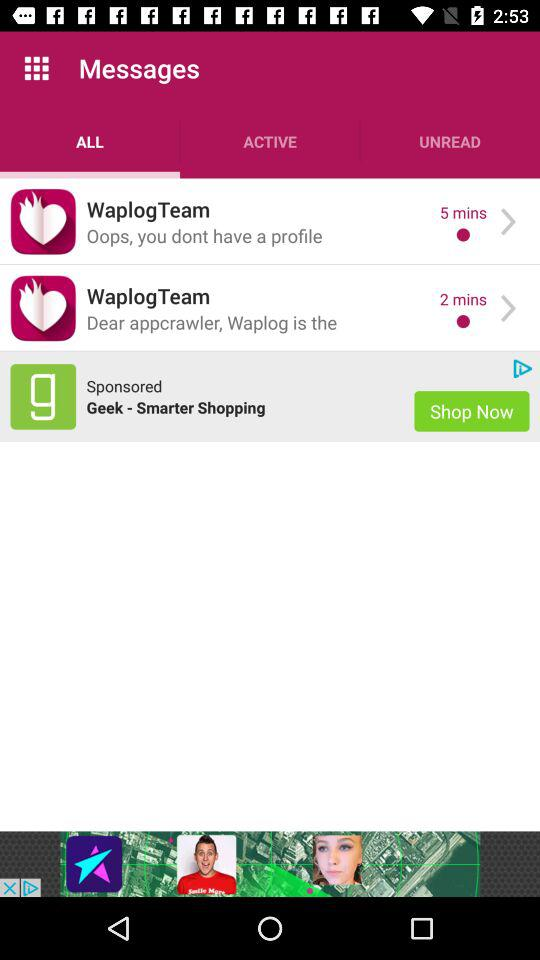How many messages are unread?
Answer the question using a single word or phrase. 2 